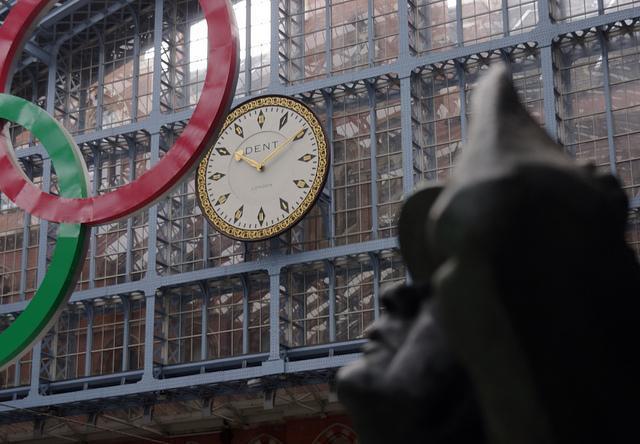How many people are visible?
Give a very brief answer. 1. 